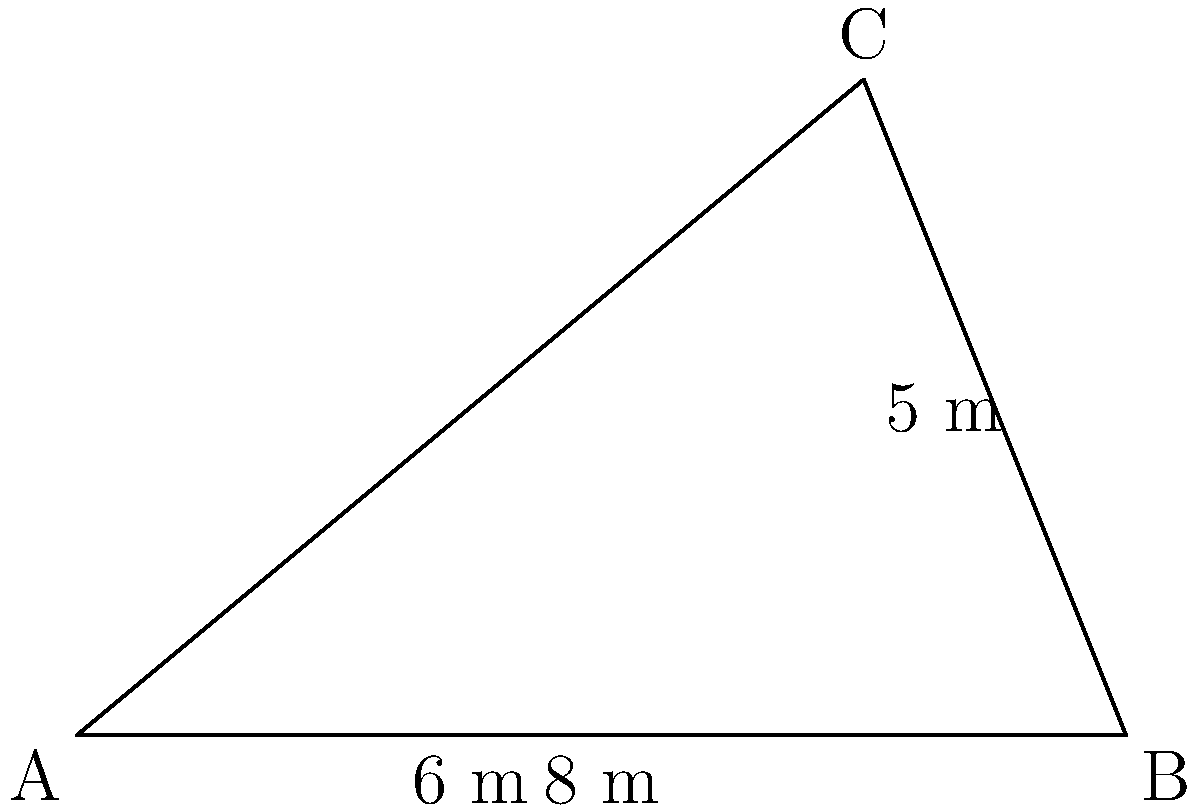As the founder of an agritech startup in Nigeria, you're helping a farmer measure an irregularly shaped field. Using triangulation methods, you've determined that the field can be approximated by a triangle with sides of 8 meters, 6 meters, and a height of 5 meters from the 8-meter side. Calculate the area of this field in square meters. To calculate the area of this triangular field, we can use the formula for the area of a triangle:

$$A = \frac{1}{2} \times base \times height$$

Given:
- Base (b) = 8 meters
- Height (h) = 5 meters

Step 1: Substitute the values into the formula:
$$A = \frac{1}{2} \times 8 \times 5$$

Step 2: Multiply the numbers:
$$A = \frac{1}{2} \times 40$$

Step 3: Calculate the final result:
$$A = 20$$

Therefore, the area of the irregularly shaped field is 20 square meters.
Answer: 20 square meters 